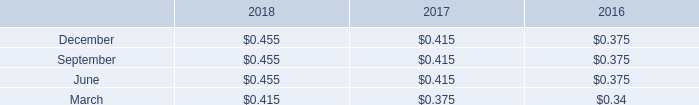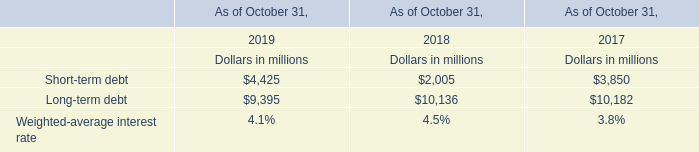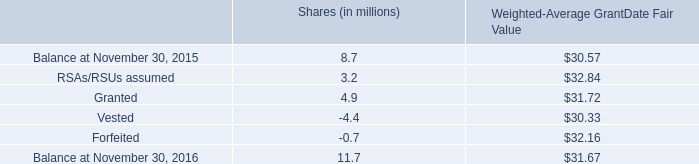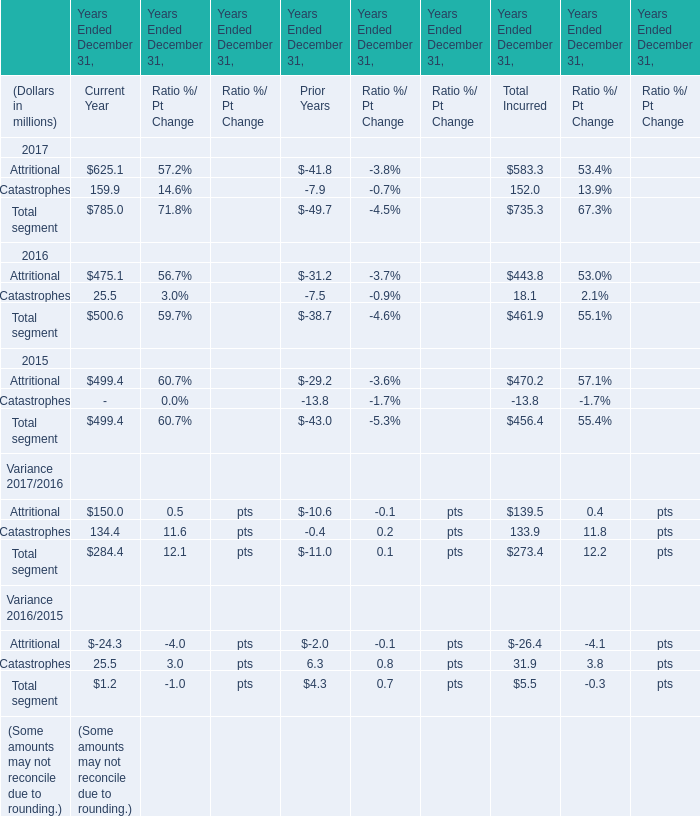Which year is Attritional in Current Year the highest? 
Answer: 2017. 